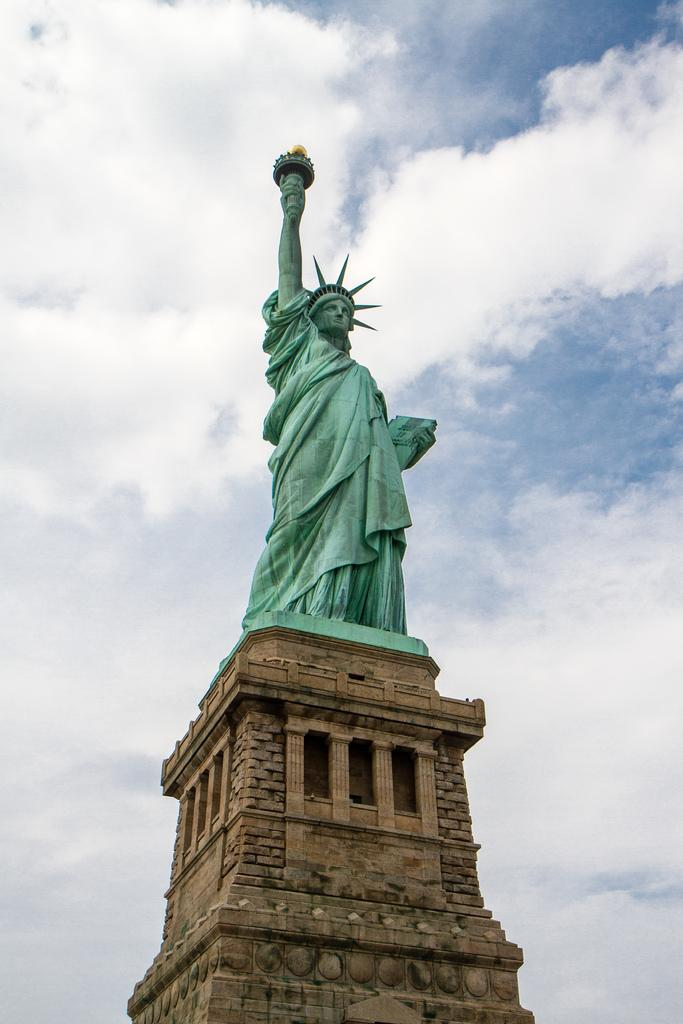What famous landmark is featured in the image? The statue of Liberty is in the image. How would you describe the sky in the image? The sky is blue and cloudy in the image. What type of material is the statue of Liberty made of in the image? The image does not provide information about the material the Statue of Liberty is made of. 